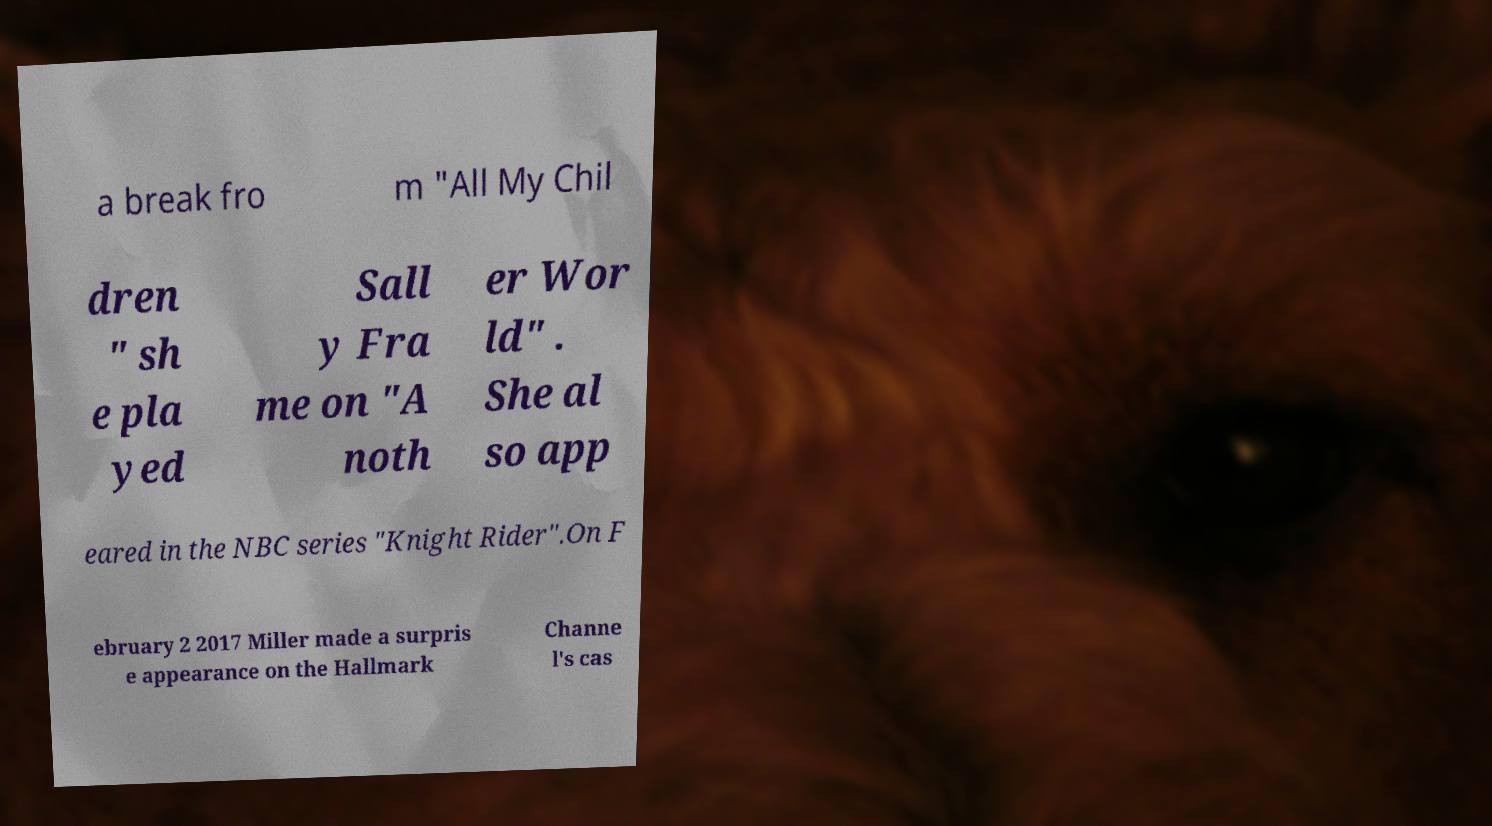Please identify and transcribe the text found in this image. a break fro m "All My Chil dren " sh e pla yed Sall y Fra me on "A noth er Wor ld" . She al so app eared in the NBC series "Knight Rider".On F ebruary 2 2017 Miller made a surpris e appearance on the Hallmark Channe l's cas 